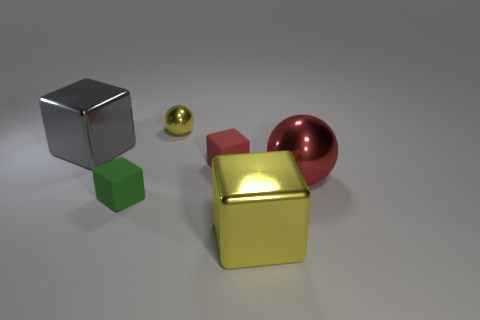There is another tiny object that is the same material as the small red object; what color is it?
Give a very brief answer. Green. Is the number of metal balls greater than the number of red cubes?
Offer a terse response. Yes. What number of things are tiny rubber blocks to the right of the tiny yellow metallic ball or gray objects?
Provide a short and direct response. 2. Is there a purple matte cylinder of the same size as the gray block?
Offer a terse response. No. Is the number of red matte cubes less than the number of purple matte cubes?
Your response must be concise. No. How many cylinders are either purple metallic things or small green objects?
Offer a terse response. 0. What number of other metallic things have the same color as the small metal thing?
Offer a terse response. 1. What size is the shiny object that is both to the left of the large yellow object and right of the large gray block?
Provide a short and direct response. Small. Is the number of big red metal balls that are in front of the tiny yellow shiny thing less than the number of purple things?
Offer a terse response. No. Are the big yellow thing and the small green cube made of the same material?
Your answer should be compact. No. 